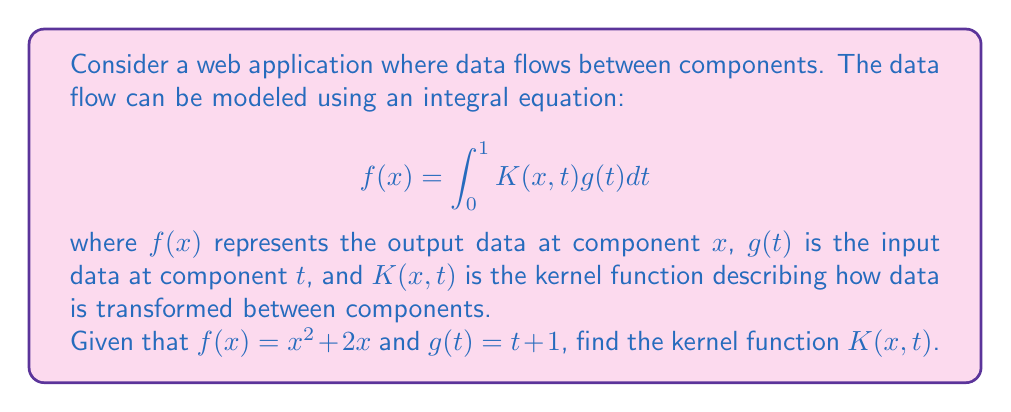Teach me how to tackle this problem. To find the kernel function $K(x,t)$, we need to follow these steps:

1. Start with the given integral equation:
   $$f(x) = \int_0^1 K(x,t)g(t)dt$$

2. Substitute the known functions:
   $$x^2 + 2x = \int_0^1 K(x,t)(t + 1)dt$$

3. To solve for $K(x,t)$, we need to differentiate both sides with respect to $x$:
   $$\frac{d}{dx}(x^2 + 2x) = \frac{d}{dx}\int_0^1 K(x,t)(t + 1)dt$$

4. Apply the Leibniz integral rule:
   $$2x + 2 = \int_0^1 \frac{\partial K(x,t)}{\partial x}(t + 1)dt$$

5. Differentiate again with respect to $x$:
   $$2 = \int_0^1 \frac{\partial^2 K(x,t)}{\partial x^2}(t + 1)dt$$

6. For this equation to hold for all $x$, we must have:
   $$\frac{\partial^2 K(x,t)}{\partial x^2} = \frac{2}{t + 1}$$

7. Integrate twice with respect to $x$:
   $$K(x,t) = \frac{2x^2}{t + 1} + A(t)x + B(t)$$
   where $A(t)$ and $B(t)$ are functions of $t$ only.

8. Substitute this back into the original equation:
   $$x^2 + 2x = \int_0^1 (\frac{2x^2}{t + 1} + A(t)x + B(t))(t + 1)dt$$

9. Simplify:
   $$x^2 + 2x = 2x^2 + x\int_0^1 A(t)(t + 1)dt + \int_0^1 B(t)(t + 1)dt$$

10. Comparing coefficients:
    $$A(t) = 2, B(t) = 0$$

Therefore, the kernel function is:
$$K(x,t) = \frac{2x^2}{t + 1} + 2x$$
Answer: $K(x,t) = \frac{2x^2}{t + 1} + 2x$ 